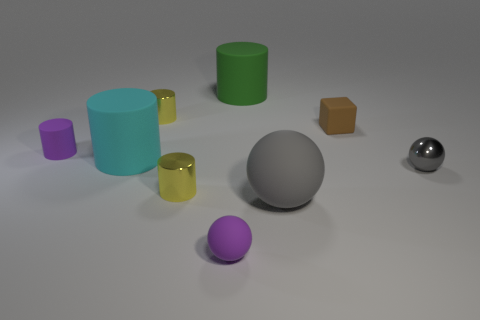What material is the other ball that is the same color as the small metal ball?
Your answer should be very brief. Rubber. Is there a big rubber cylinder in front of the gray object that is on the right side of the rubber block that is behind the purple rubber sphere?
Your answer should be very brief. No. Does the cyan matte thing have the same shape as the gray shiny thing?
Make the answer very short. No. Are there fewer big gray rubber spheres that are on the right side of the tiny brown object than small blue rubber cylinders?
Offer a very short reply. No. There is a tiny matte thing on the left side of the small yellow cylinder that is behind the large rubber cylinder to the left of the purple matte sphere; what color is it?
Provide a succinct answer. Purple. How many metallic objects are either purple spheres or small red cubes?
Keep it short and to the point. 0. Is the size of the cyan cylinder the same as the gray rubber sphere?
Provide a short and direct response. Yes. Are there fewer small balls in front of the small matte ball than small gray shiny balls in front of the big gray matte ball?
Provide a succinct answer. No. Are there any other things that have the same size as the cyan object?
Make the answer very short. Yes. The cyan cylinder has what size?
Give a very brief answer. Large. 